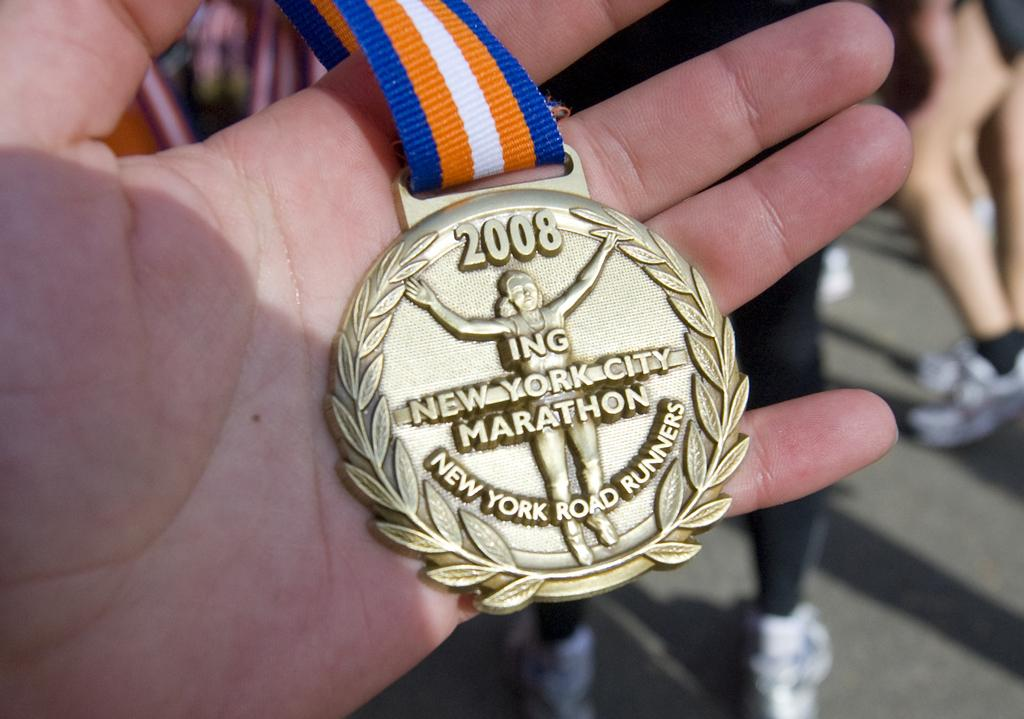What is the person in the image holding? The person is holding a medal in the image. Can you describe the medal's tag? The medal has a blue, orange, and white tag. What can be seen in the background of the image? There are people standing in the background of the image. What type of nail is being hammered into the marble in the image? There is no nail or marble present in the image; it features a person holding a medal with a blue, orange, and white tag. 